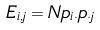<formula> <loc_0><loc_0><loc_500><loc_500>E _ { i , j } = N p _ { i \cdot } p _ { \cdot j }</formula> 